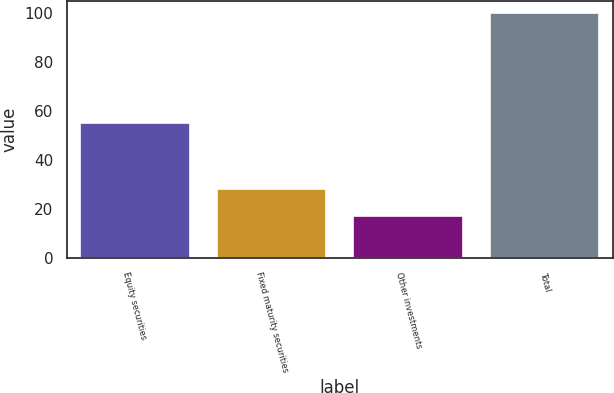Convert chart to OTSL. <chart><loc_0><loc_0><loc_500><loc_500><bar_chart><fcel>Equity securities<fcel>Fixed maturity securities<fcel>Other investments<fcel>Total<nl><fcel>55<fcel>28<fcel>17<fcel>100<nl></chart> 